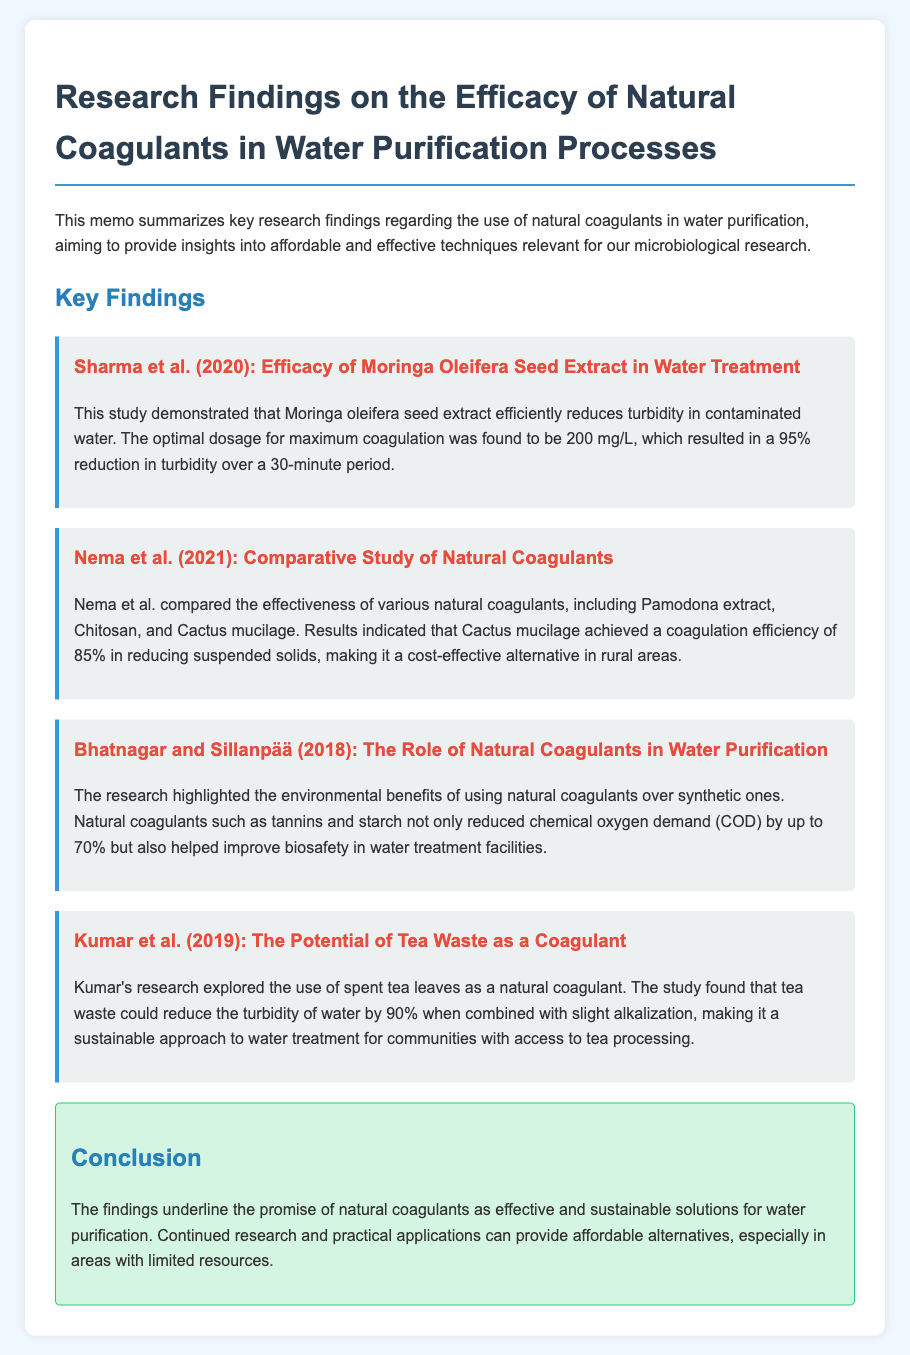What was the optimal dosage of Moringa oleifera seed extract? The document states that the optimal dosage for maximum coagulation was found to be 200 mg/L.
Answer: 200 mg/L What reduction in turbidity was achieved by using Moringa oleifera seed extract? The study demonstrated a 95% reduction in turbidity over a 30-minute period.
Answer: 95% Which natural coagulant achieved an 85% coagulation efficiency? Nema et al. found that Cactus mucilage achieved a coagulation efficiency of 85% in reducing suspended solids.
Answer: Cactus mucilage What reduction in chemical oxygen demand (COD) was noted by Bhatnagar and Sillanpää? The research highlighted that natural coagulants reduced chemical oxygen demand (COD) by up to 70%.
Answer: 70% What was the turbidity reduction percentage when using spent tea leaves? Kumar's research found that tea waste could reduce the turbidity of water by 90%.
Answer: 90% What year was the study by Nema et al. published? The document states that the study by Nema et al. was published in 2021.
Answer: 2021 What is the primary focus of the memo? The memo summarizes key research findings regarding the use of natural coagulants in water purification.
Answer: Natural coagulants in water purification What environmental benefit is mentioned in the study by Bhatnagar and Sillanpää? The research highlighted the environmental benefits of using natural coagulants over synthetic ones.
Answer: Environmental benefits Which natural coagulant was explored by Kumar et al.? Kumar's research explored the use of spent tea leaves as a natural coagulant.
Answer: Spent tea leaves 